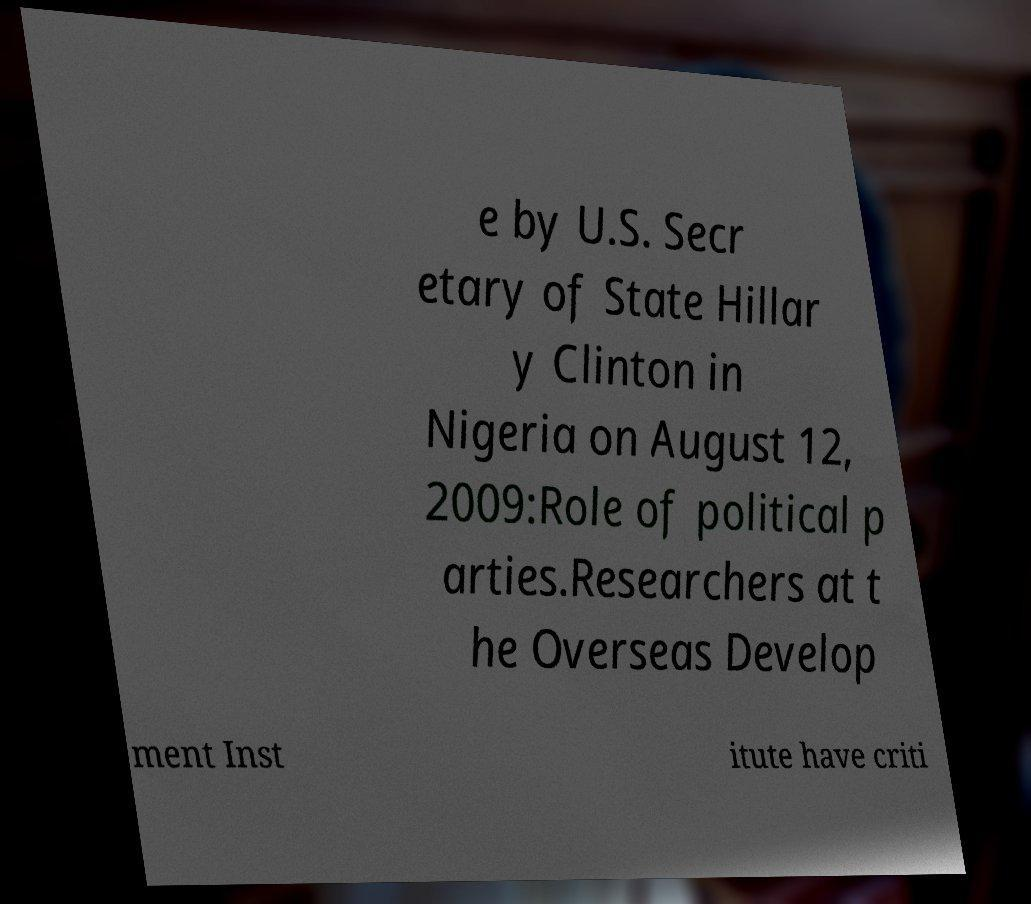I need the written content from this picture converted into text. Can you do that? e by U.S. Secr etary of State Hillar y Clinton in Nigeria on August 12, 2009:Role of political p arties.Researchers at t he Overseas Develop ment Inst itute have criti 